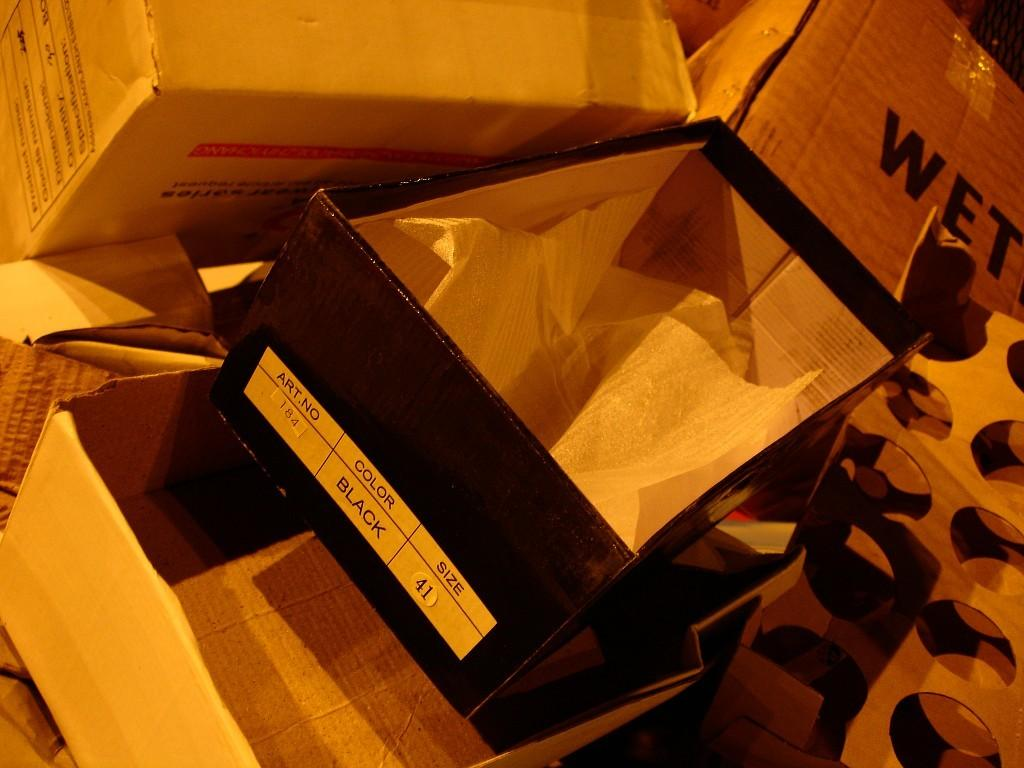<image>
Provide a brief description of the given image. an empty shoe box that says color black on the side of it 